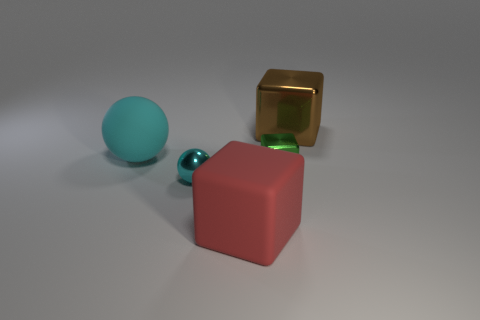There is a small metal sphere; is it the same color as the large object that is in front of the matte sphere?
Your answer should be very brief. No. The big thing that is the same color as the tiny metal ball is what shape?
Your answer should be very brief. Sphere. What is the shape of the big red rubber thing?
Ensure brevity in your answer.  Cube. Does the small metallic block have the same color as the big matte cube?
Your answer should be very brief. No. How many objects are big blocks that are right of the green shiny object or red rubber things?
Offer a very short reply. 2. The cyan ball that is the same material as the tiny green object is what size?
Your answer should be very brief. Small. Are there more small things that are behind the brown metallic block than big red rubber spheres?
Your answer should be very brief. No. There is a brown object; does it have the same shape as the cyan thing that is on the right side of the cyan rubber ball?
Your response must be concise. No. How many large objects are either green shiny objects or cyan rubber spheres?
Offer a terse response. 1. What size is the thing that is the same color as the tiny ball?
Make the answer very short. Large. 